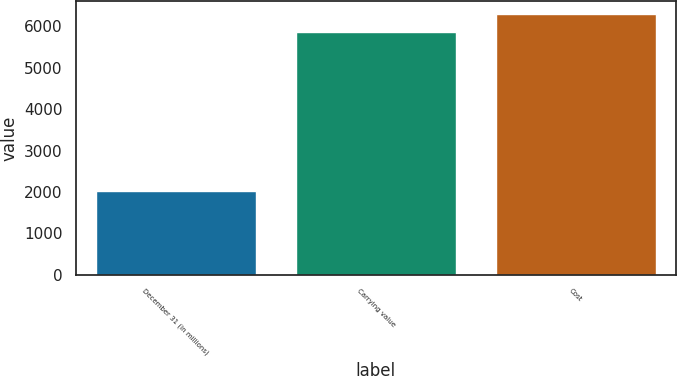<chart> <loc_0><loc_0><loc_500><loc_500><bar_chart><fcel>December 31 (in millions)<fcel>Carrying value<fcel>Cost<nl><fcel>2014<fcel>5866<fcel>6292.7<nl></chart> 